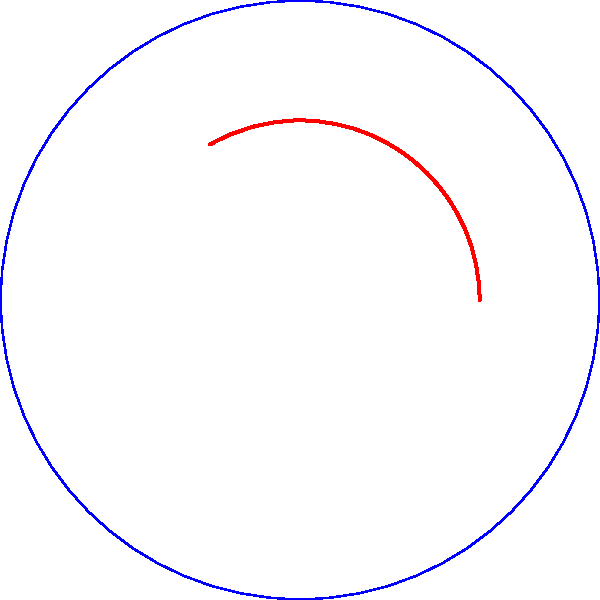In a circular space habitat design, an arc-shaped structure needs to be constructed. The outer radius of the habitat is $R = 50$ m, and the inner radius of the arc structure is $r = 30$ m. If the central angle of the arc is $\theta = 120°$, calculate the length of the outer arc of the structure. Round your answer to the nearest meter. To calculate the length of the outer arc, we'll follow these steps:

1) The formula for arc length is:
   $s = r\theta$
   where $s$ is the arc length, $r$ is the radius, and $\theta$ is the central angle in radians.

2) We're given the angle in degrees, so we need to convert it to radians:
   $\theta_{rad} = \theta_{deg} \cdot \frac{\pi}{180°}$
   $\theta_{rad} = 120° \cdot \frac{\pi}{180°} = \frac{2\pi}{3}$ radians

3) Now we can use the arc length formula with the outer radius $R = 50$ m:
   $s = R\theta_{rad}$
   $s = 50 \cdot \frac{2\pi}{3}$

4) Simplify:
   $s = \frac{100\pi}{3}$ m

5) Calculate and round to the nearest meter:
   $s \approx 104.72$ m
   Rounded to the nearest meter: $105$ m

Therefore, the length of the outer arc of the structure is approximately 105 meters.
Answer: 105 m 